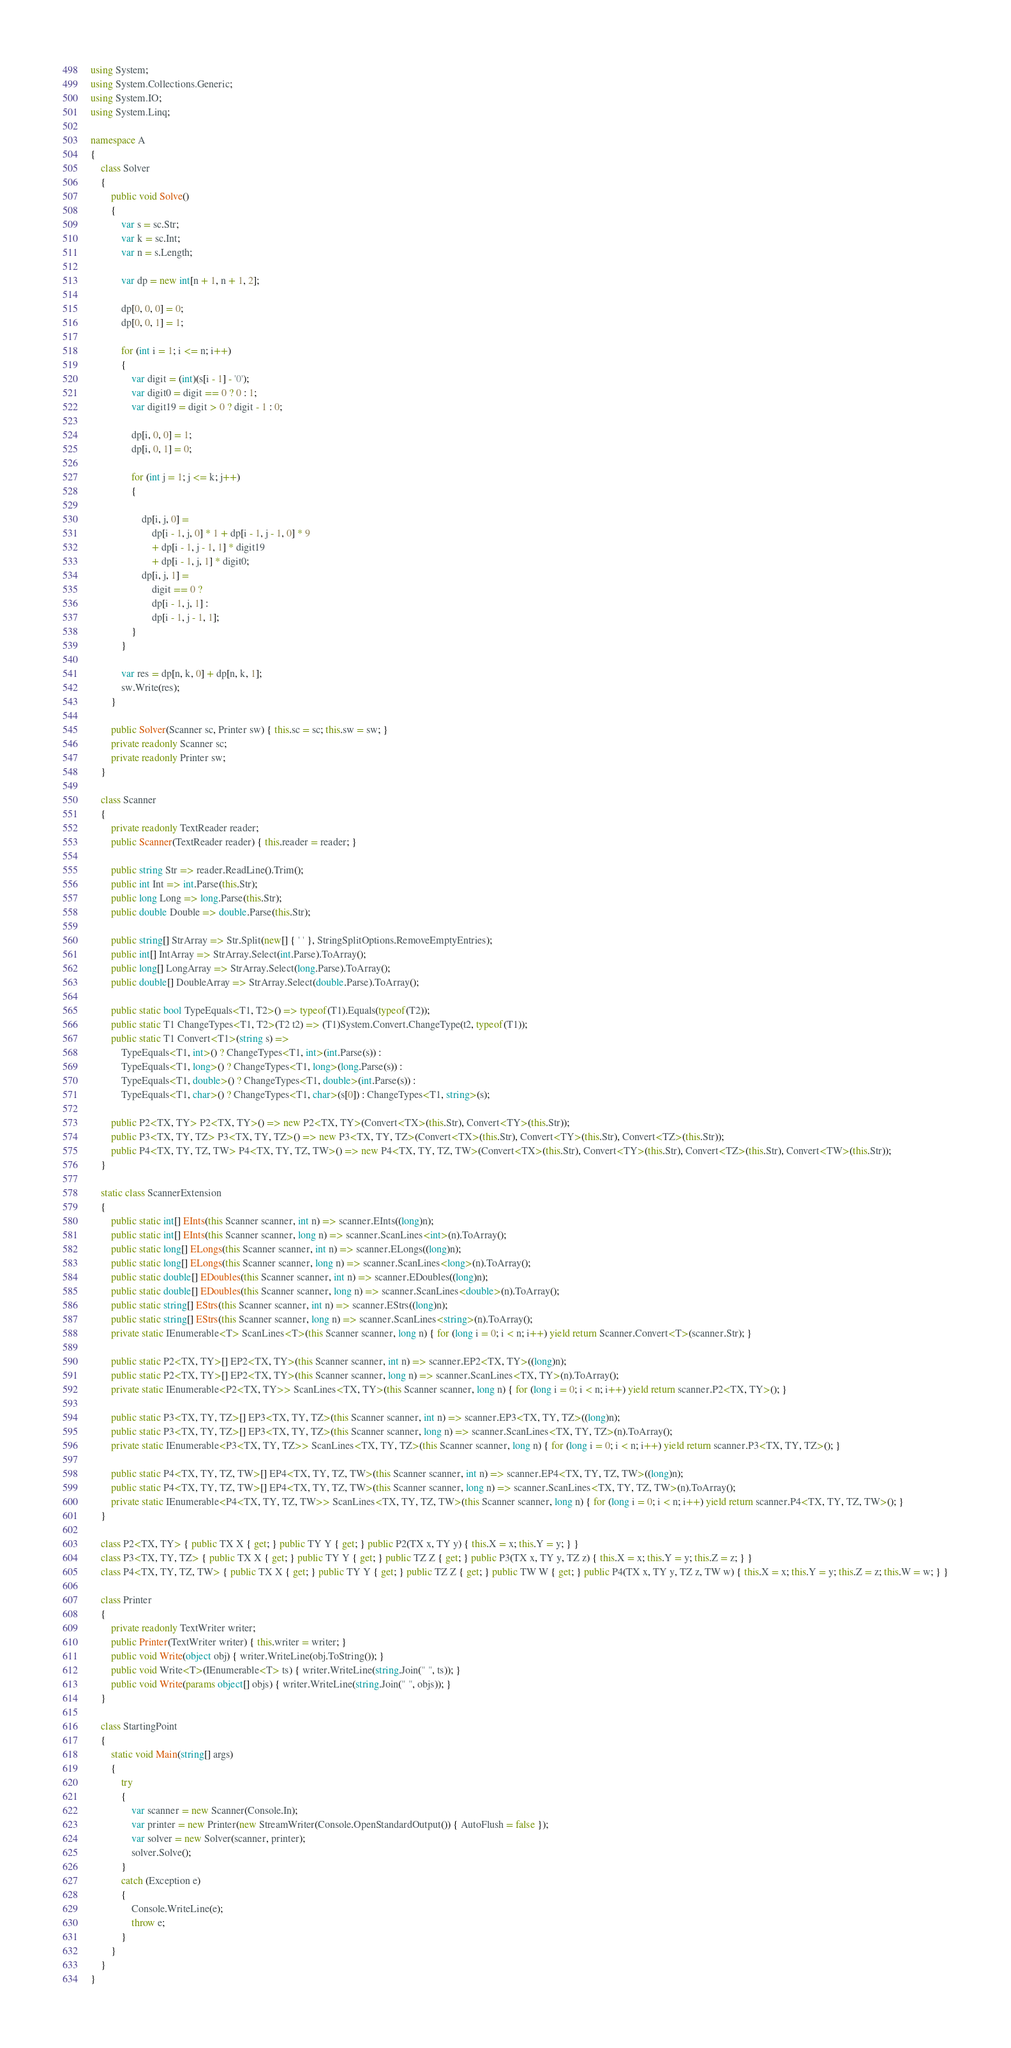<code> <loc_0><loc_0><loc_500><loc_500><_C#_>using System;
using System.Collections.Generic;
using System.IO;
using System.Linq;

namespace A
{
    class Solver
    {
        public void Solve()
        {
            var s = sc.Str;
            var k = sc.Int;
            var n = s.Length;

            var dp = new int[n + 1, n + 1, 2];

            dp[0, 0, 0] = 0;
            dp[0, 0, 1] = 1;

            for (int i = 1; i <= n; i++)
            {
                var digit = (int)(s[i - 1] - '0');
                var digit0 = digit == 0 ? 0 : 1;
                var digit19 = digit > 0 ? digit - 1 : 0;

                dp[i, 0, 0] = 1;
                dp[i, 0, 1] = 0;

                for (int j = 1; j <= k; j++)
                {

                    dp[i, j, 0] =
                        dp[i - 1, j, 0] * 1 + dp[i - 1, j - 1, 0] * 9
                        + dp[i - 1, j - 1, 1] * digit19
                        + dp[i - 1, j, 1] * digit0;
                    dp[i, j, 1] =
                        digit == 0 ?
                        dp[i - 1, j, 1] :
                        dp[i - 1, j - 1, 1];
                }
            }

            var res = dp[n, k, 0] + dp[n, k, 1];
            sw.Write(res);
        }

        public Solver(Scanner sc, Printer sw) { this.sc = sc; this.sw = sw; }
        private readonly Scanner sc;
        private readonly Printer sw;
    }

    class Scanner
    {
        private readonly TextReader reader;
        public Scanner(TextReader reader) { this.reader = reader; }

        public string Str => reader.ReadLine().Trim();
        public int Int => int.Parse(this.Str);
        public long Long => long.Parse(this.Str);
        public double Double => double.Parse(this.Str);

        public string[] StrArray => Str.Split(new[] { ' ' }, StringSplitOptions.RemoveEmptyEntries);
        public int[] IntArray => StrArray.Select(int.Parse).ToArray();
        public long[] LongArray => StrArray.Select(long.Parse).ToArray();
        public double[] DoubleArray => StrArray.Select(double.Parse).ToArray();

        public static bool TypeEquals<T1, T2>() => typeof(T1).Equals(typeof(T2));
        public static T1 ChangeTypes<T1, T2>(T2 t2) => (T1)System.Convert.ChangeType(t2, typeof(T1));
        public static T1 Convert<T1>(string s) =>
            TypeEquals<T1, int>() ? ChangeTypes<T1, int>(int.Parse(s)) :
            TypeEquals<T1, long>() ? ChangeTypes<T1, long>(long.Parse(s)) :
            TypeEquals<T1, double>() ? ChangeTypes<T1, double>(int.Parse(s)) :
            TypeEquals<T1, char>() ? ChangeTypes<T1, char>(s[0]) : ChangeTypes<T1, string>(s);

        public P2<TX, TY> P2<TX, TY>() => new P2<TX, TY>(Convert<TX>(this.Str), Convert<TY>(this.Str));
        public P3<TX, TY, TZ> P3<TX, TY, TZ>() => new P3<TX, TY, TZ>(Convert<TX>(this.Str), Convert<TY>(this.Str), Convert<TZ>(this.Str));
        public P4<TX, TY, TZ, TW> P4<TX, TY, TZ, TW>() => new P4<TX, TY, TZ, TW>(Convert<TX>(this.Str), Convert<TY>(this.Str), Convert<TZ>(this.Str), Convert<TW>(this.Str));
    }

    static class ScannerExtension
    {
        public static int[] EInts(this Scanner scanner, int n) => scanner.EInts((long)n);
        public static int[] EInts(this Scanner scanner, long n) => scanner.ScanLines<int>(n).ToArray();
        public static long[] ELongs(this Scanner scanner, int n) => scanner.ELongs((long)n);
        public static long[] ELongs(this Scanner scanner, long n) => scanner.ScanLines<long>(n).ToArray();
        public static double[] EDoubles(this Scanner scanner, int n) => scanner.EDoubles((long)n);
        public static double[] EDoubles(this Scanner scanner, long n) => scanner.ScanLines<double>(n).ToArray();
        public static string[] EStrs(this Scanner scanner, int n) => scanner.EStrs((long)n);
        public static string[] EStrs(this Scanner scanner, long n) => scanner.ScanLines<string>(n).ToArray();
        private static IEnumerable<T> ScanLines<T>(this Scanner scanner, long n) { for (long i = 0; i < n; i++) yield return Scanner.Convert<T>(scanner.Str); }

        public static P2<TX, TY>[] EP2<TX, TY>(this Scanner scanner, int n) => scanner.EP2<TX, TY>((long)n);
        public static P2<TX, TY>[] EP2<TX, TY>(this Scanner scanner, long n) => scanner.ScanLines<TX, TY>(n).ToArray();
        private static IEnumerable<P2<TX, TY>> ScanLines<TX, TY>(this Scanner scanner, long n) { for (long i = 0; i < n; i++) yield return scanner.P2<TX, TY>(); }

        public static P3<TX, TY, TZ>[] EP3<TX, TY, TZ>(this Scanner scanner, int n) => scanner.EP3<TX, TY, TZ>((long)n);
        public static P3<TX, TY, TZ>[] EP3<TX, TY, TZ>(this Scanner scanner, long n) => scanner.ScanLines<TX, TY, TZ>(n).ToArray();
        private static IEnumerable<P3<TX, TY, TZ>> ScanLines<TX, TY, TZ>(this Scanner scanner, long n) { for (long i = 0; i < n; i++) yield return scanner.P3<TX, TY, TZ>(); }

        public static P4<TX, TY, TZ, TW>[] EP4<TX, TY, TZ, TW>(this Scanner scanner, int n) => scanner.EP4<TX, TY, TZ, TW>((long)n);
        public static P4<TX, TY, TZ, TW>[] EP4<TX, TY, TZ, TW>(this Scanner scanner, long n) => scanner.ScanLines<TX, TY, TZ, TW>(n).ToArray();
        private static IEnumerable<P4<TX, TY, TZ, TW>> ScanLines<TX, TY, TZ, TW>(this Scanner scanner, long n) { for (long i = 0; i < n; i++) yield return scanner.P4<TX, TY, TZ, TW>(); }
    }

    class P2<TX, TY> { public TX X { get; } public TY Y { get; } public P2(TX x, TY y) { this.X = x; this.Y = y; } }
    class P3<TX, TY, TZ> { public TX X { get; } public TY Y { get; } public TZ Z { get; } public P3(TX x, TY y, TZ z) { this.X = x; this.Y = y; this.Z = z; } }
    class P4<TX, TY, TZ, TW> { public TX X { get; } public TY Y { get; } public TZ Z { get; } public TW W { get; } public P4(TX x, TY y, TZ z, TW w) { this.X = x; this.Y = y; this.Z = z; this.W = w; } }

    class Printer
    {
        private readonly TextWriter writer;
        public Printer(TextWriter writer) { this.writer = writer; }
        public void Write(object obj) { writer.WriteLine(obj.ToString()); }
        public void Write<T>(IEnumerable<T> ts) { writer.WriteLine(string.Join(" ", ts)); }
        public void Write(params object[] objs) { writer.WriteLine(string.Join(" ", objs)); }
    }

    class StartingPoint
    {
        static void Main(string[] args)
        {
            try
            {
                var scanner = new Scanner(Console.In);
                var printer = new Printer(new StreamWriter(Console.OpenStandardOutput()) { AutoFlush = false });
                var solver = new Solver(scanner, printer);
                solver.Solve();
            }
            catch (Exception e)
            {
                Console.WriteLine(e);
                throw e;
            }
        }
    }
}</code> 